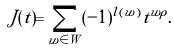Convert formula to latex. <formula><loc_0><loc_0><loc_500><loc_500>J ( t ) = \sum _ { w \in W } ( - 1 ) ^ { l ( w ) } t ^ { w \rho } .</formula> 